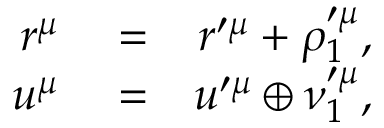<formula> <loc_0><loc_0><loc_500><loc_500>\begin{array} { r l r } { r ^ { \mu } } & = } & { r ^ { \prime \mu } + \rho _ { 1 } ^ { \prime \mu } , } \\ { u ^ { \mu } } & = } & { u ^ { \prime \mu } \oplus \nu _ { 1 } ^ { \prime \mu } , } \end{array}</formula> 